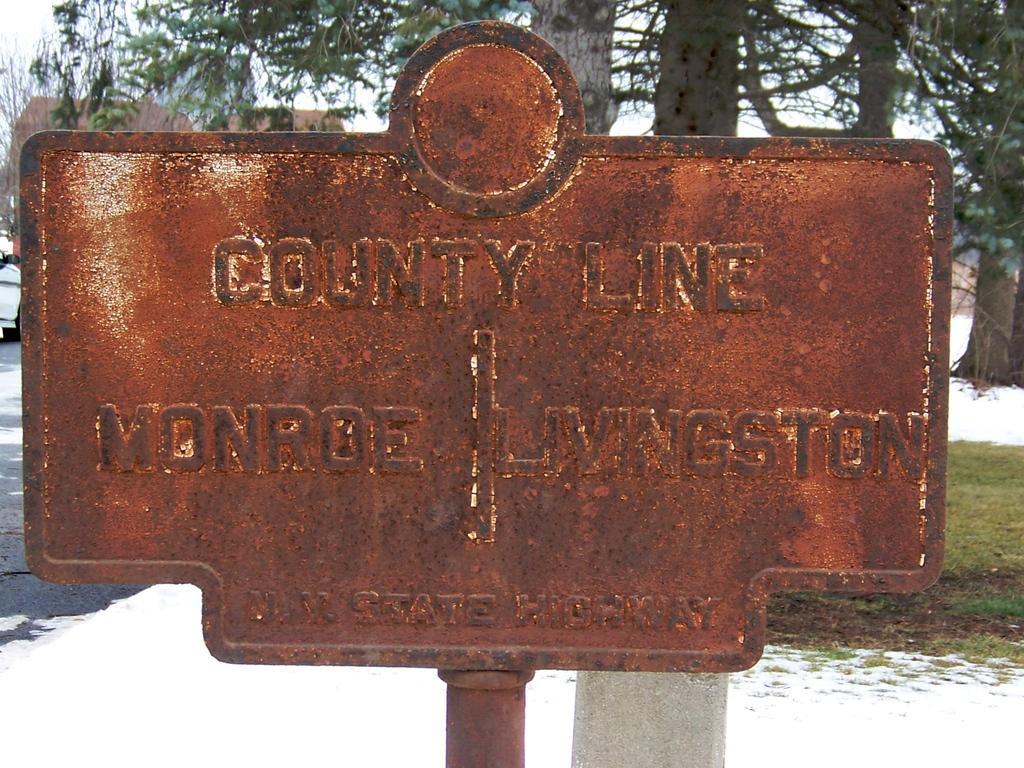How would you summarize this image in a sentence or two? In this image, I can see a board with some text on it. In the background, there are trees. On the left corner of the image, I can see a vehicle on the road. At the bottom of the image, I can see the grass and snow. 